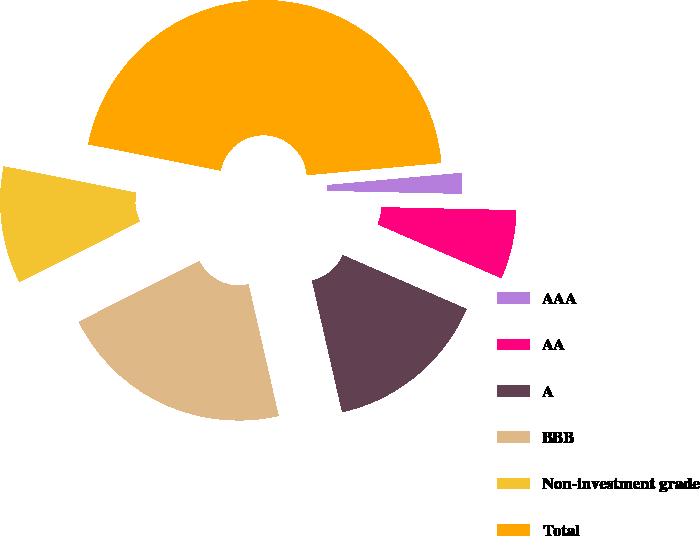Convert chart to OTSL. <chart><loc_0><loc_0><loc_500><loc_500><pie_chart><fcel>AAA<fcel>AA<fcel>A<fcel>BBB<fcel>Non-investment grade<fcel>Total<nl><fcel>1.8%<fcel>6.17%<fcel>14.89%<fcel>21.17%<fcel>10.53%<fcel>45.44%<nl></chart> 